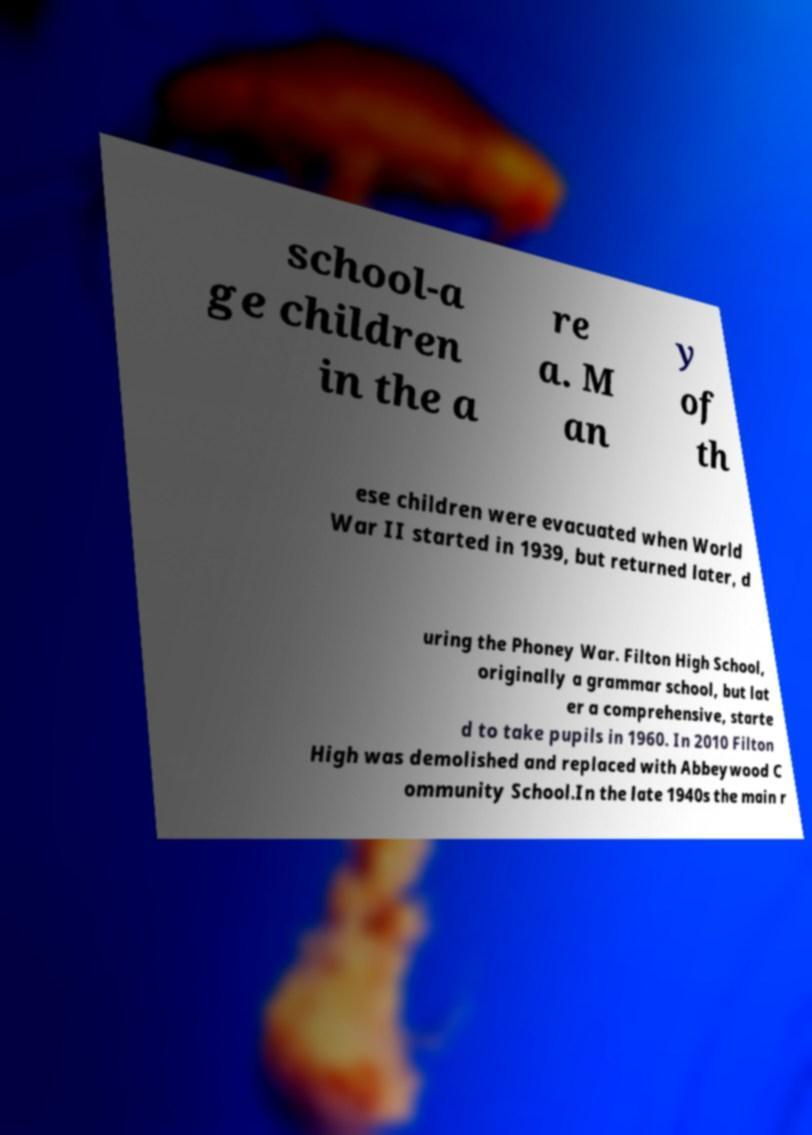What messages or text are displayed in this image? I need them in a readable, typed format. school-a ge children in the a re a. M an y of th ese children were evacuated when World War II started in 1939, but returned later, d uring the Phoney War. Filton High School, originally a grammar school, but lat er a comprehensive, starte d to take pupils in 1960. In 2010 Filton High was demolished and replaced with Abbeywood C ommunity School.In the late 1940s the main r 